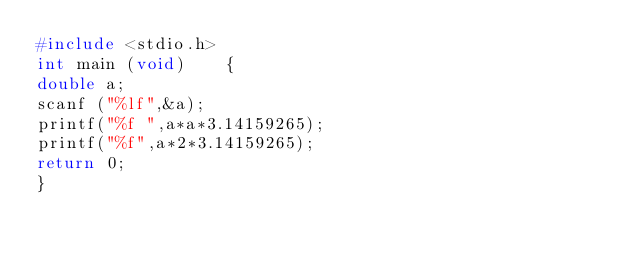Convert code to text. <code><loc_0><loc_0><loc_500><loc_500><_C_>#include <stdio.h>
int main (void)    {
double a;
scanf ("%lf",&a);
printf("%f ",a*a*3.14159265);
printf("%f",a*2*3.14159265);
return 0;
}</code> 